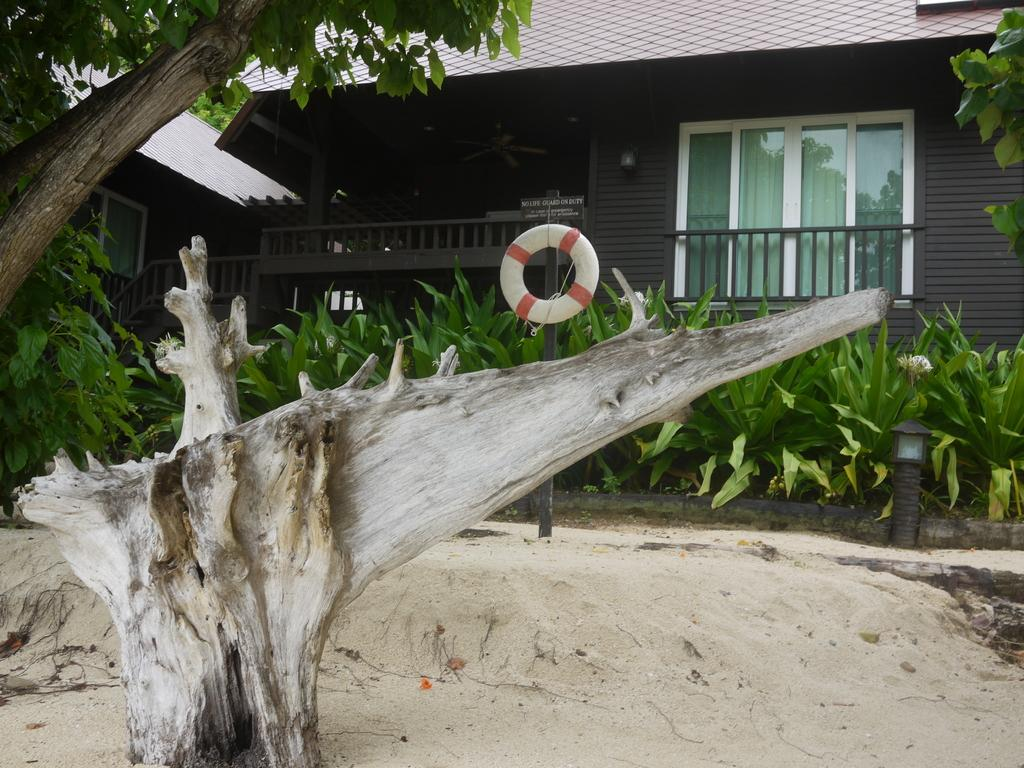What is the main subject of the image? The main subject of the image is a tree. Can you describe the tree in more detail? Yes, there is a tree trunk and a tree in the image. What else can be seen in the image besides the tree? There are plants, poles on the ground, a swim tube, a name board, and a house with windows in the background. Can you tell me how many people are sitting on the sofa in the image? There is no sofa present in the image. What type of touch can be seen between the tree and the plants in the image? There is no touch between the tree and the plants in the image; they are separate objects. 